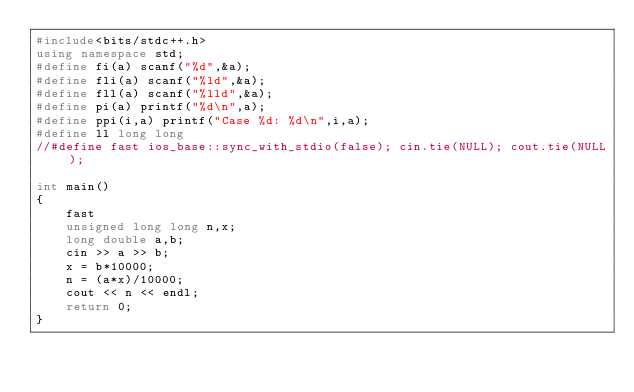Convert code to text. <code><loc_0><loc_0><loc_500><loc_500><_C++_>#include<bits/stdc++.h>
using namespace std;
#define fi(a) scanf("%d",&a);
#define fli(a) scanf("%ld",&a);
#define fll(a) scanf("%lld",&a);
#define pi(a) printf("%d\n",a);
#define ppi(i,a) printf("Case %d: %d\n",i,a);
#define ll long long
//#define fast ios_base::sync_with_stdio(false); cin.tie(NULL); cout.tie(NULL);

int main()
{
    fast
    unsigned long long n,x;
    long double a,b;
    cin >> a >> b;
    x = b*10000;
    n = (a*x)/10000;
    cout << n << endl;
    return 0;
}
</code> 